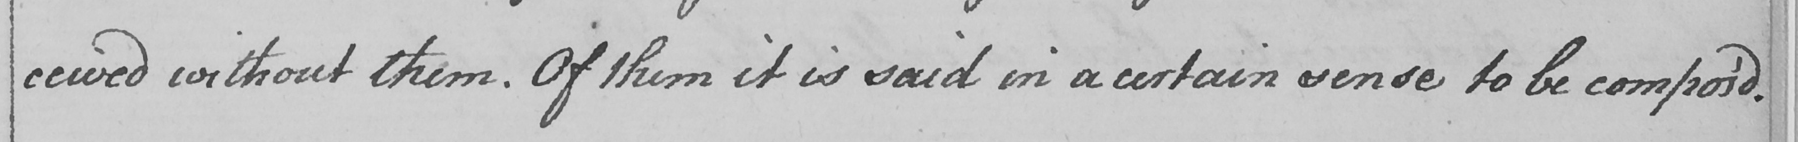What does this handwritten line say? ceived without them . Of them it is said in a certain sense to be compos ' d 